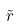<formula> <loc_0><loc_0><loc_500><loc_500>\tilde { r }</formula> 